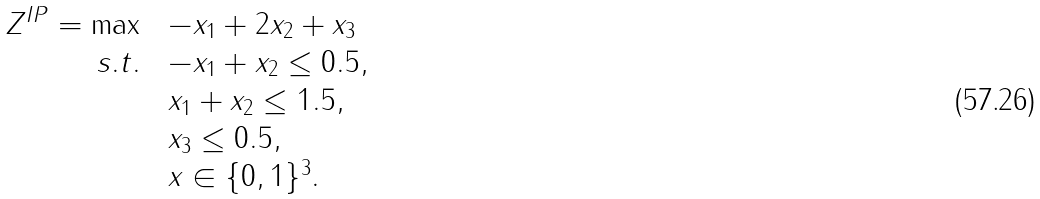<formula> <loc_0><loc_0><loc_500><loc_500>\begin{array} { r l } Z ^ { I P } = \max \ & - x _ { 1 } + 2 x _ { 2 } + x _ { 3 } \\ s . t . \ & - x _ { 1 } + x _ { 2 } \leq 0 . 5 , \\ & x _ { 1 } + x _ { 2 } \leq 1 . 5 , \\ & x _ { 3 } \leq 0 . 5 , \\ & x \in \{ 0 , 1 \} ^ { 3 } . \end{array}</formula> 